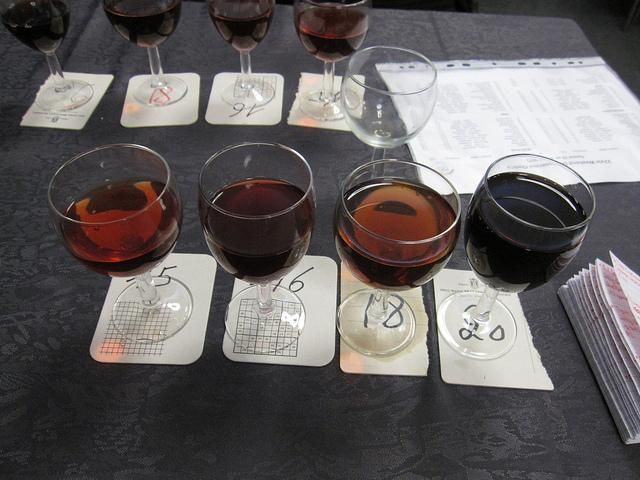What activity is the person taking this pic taking part in here? wine tasting 